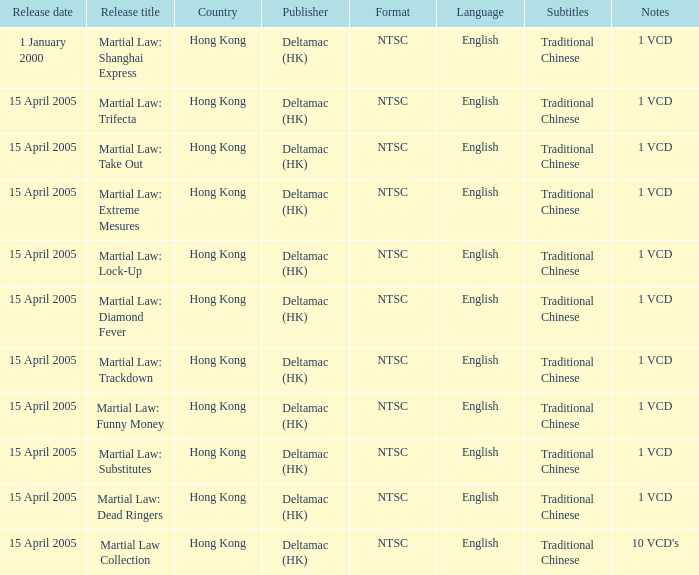Who was the publisher of Martial Law: Dead Ringers? Deltamac (HK). 